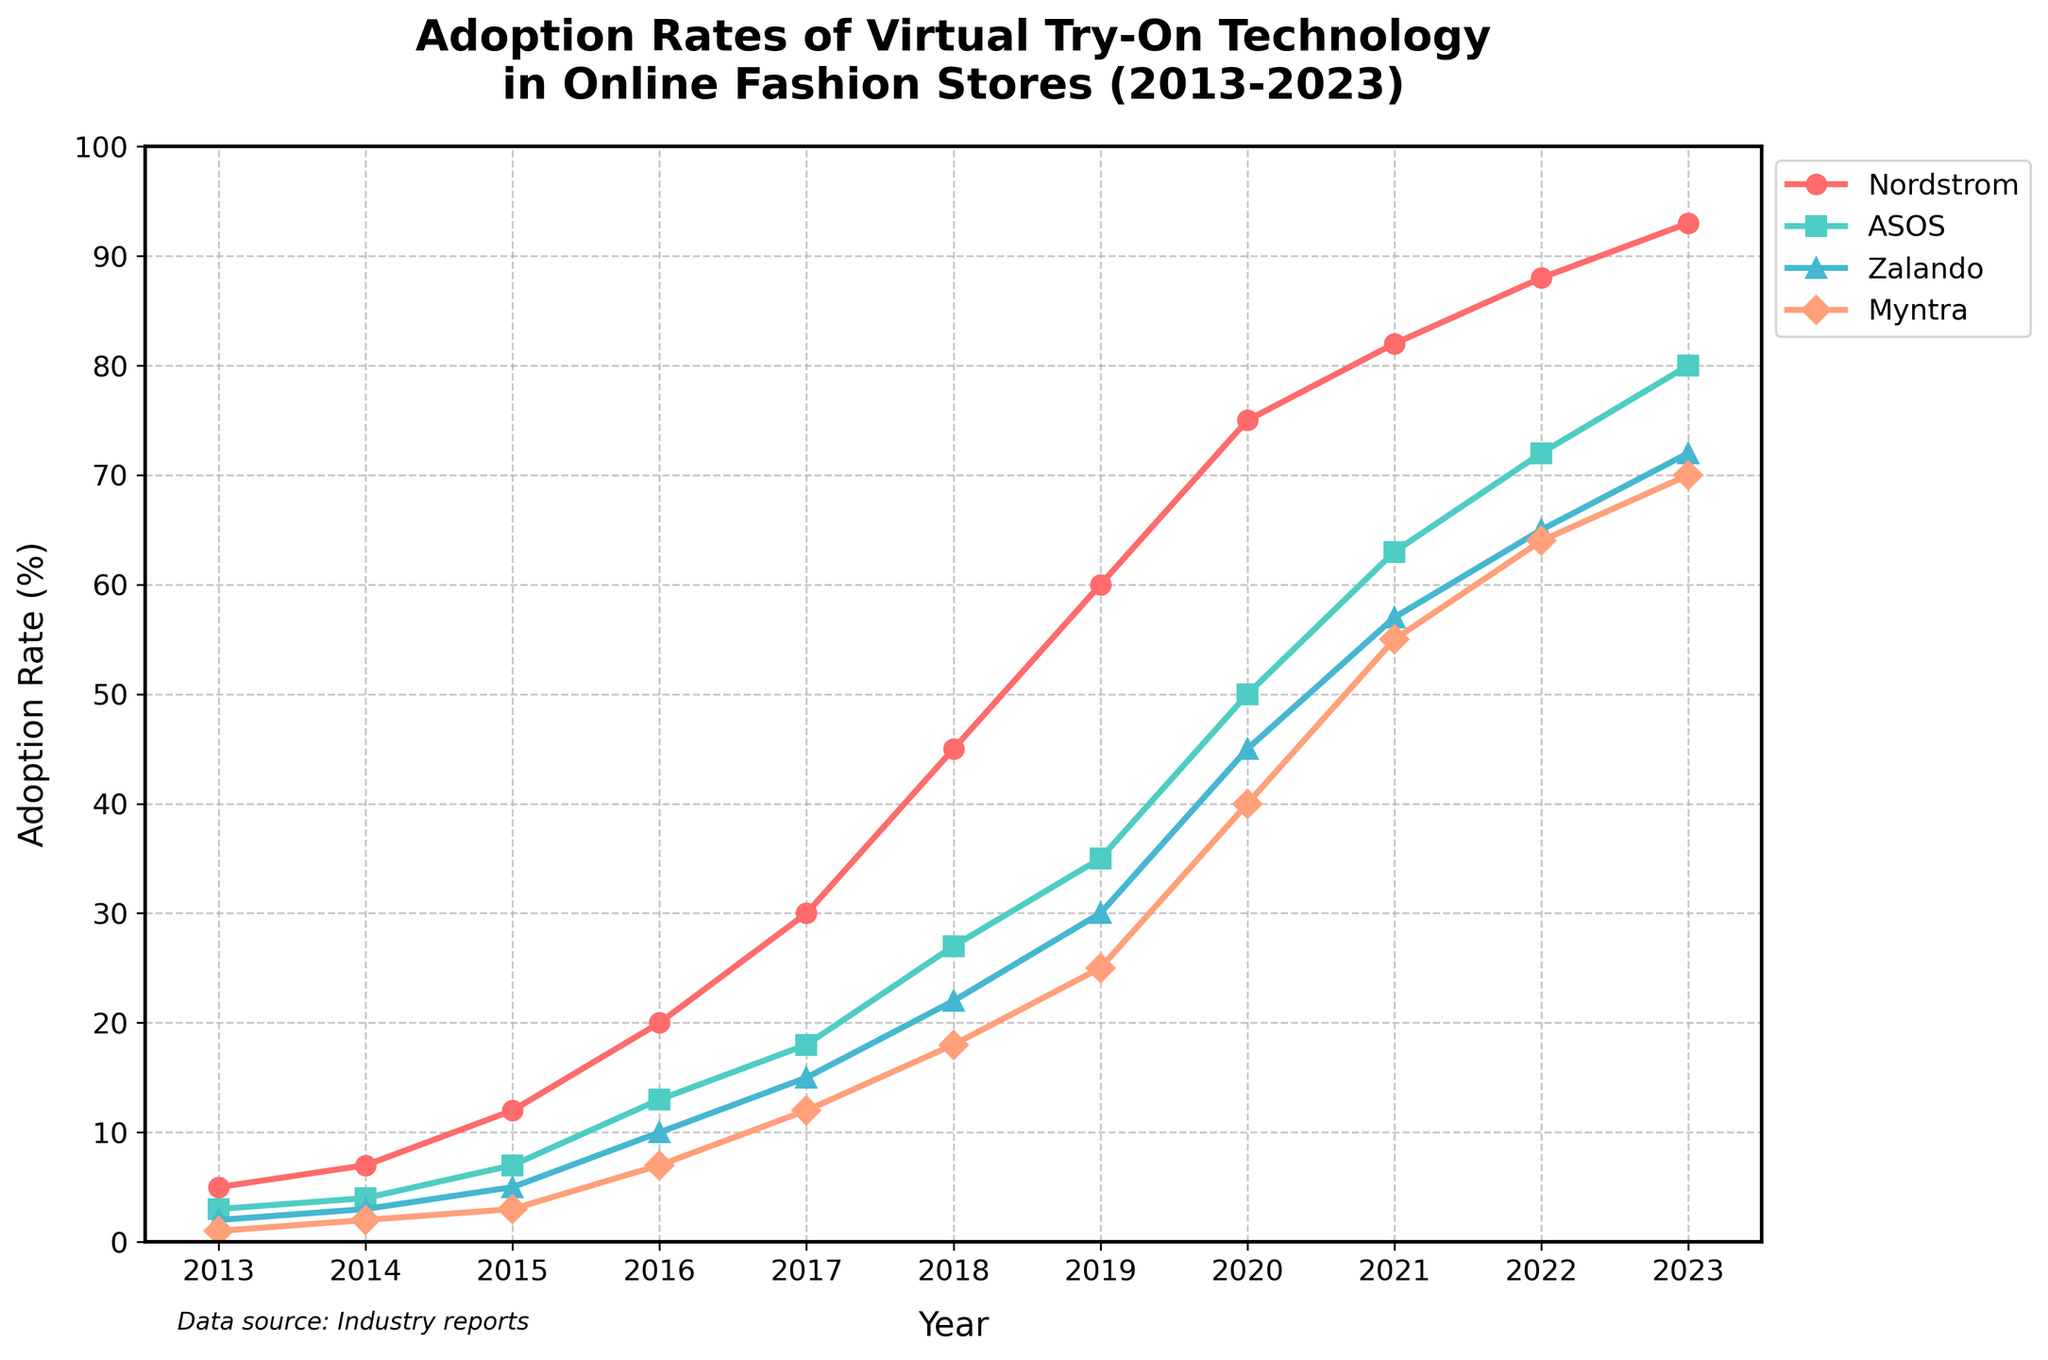what is the title of the figure? The title is typically located at the top of the plot. It provides a summary of what is being shown in the chart. In this case, the title reads "Adoption Rates of Virtual Try-On Technology in Online Fashion Stores (2013-2023)".
Answer: Adoption Rates of Virtual Try-On Technology in Online Fashion Stores (2013-2023) which company had the highest adoption rate in 2023? To find out which company had the highest adoption rate in 2023, look at the end points of each line on the far right of the graph. The highest point on the y-axis corresponds to Nordstrom, which had an adoption rate of 93%.
Answer: Nordstrom between which years did ASOS see the steepest rise in adoption rates? To identify the period with the steepest rise, look at the slope of the line for ASOS. Rapid increases are indicated by steeper slopes. Between 2019 and 2020, the line is steepest, suggesting the largest increase in that period.
Answer: 2019-2020 how much did Zalando's adoption rate increase from 2016 to 2019? First, note Zalando's adoption rates for 2016 and 2019. In 2016, the rate was 10%, and in 2019, it was 30%. The increase is calculated as 30% - 10% = 20%.
Answer: 20% which company had the slowest initial adoption rate from 2013 to 2015? Compare the slopes of each line from 2013 to 2015. The line with the smallest slope indicates the slowest adoption rate. Myntra had the smallest increase, moving from 1% to 3%.
Answer: Myntra in what year did all four companies exceed a 50% adoption rate? Look at the y-axis and find the 50% mark. Then trace horizontally to see when all four lines cross this threshold. The year when all companies exceed 50% is 2021.
Answer: 2021 which company showed a consistent rise in adoption rates every year without any decline? Examine the trajectories of all four lines. Nordstrom's adoption rate increases every year without any decline, showing a consistent rise.
Answer: Nordstrom did ASOS or Myntra have the bigger increase in adoption rate between 2017 and 2023? Calculate the difference in adoption rates for ASOS and Myntra between 2017 and 2023. For ASOS, the increase is 80% - 18% = 62%. For Myntra, it is 70% - 12% = 58%. ASOS has the bigger increase.
Answer: ASOS which company had the smallest adoption rate difference between 2013 and 2023? Calculate the absolute differences for each company over the period: Nordstrom (93% - 5%), ASOS (80% - 3%), Zalando (72% - 2%), Myntra (70% - 1%). Zalando has the smallest difference, 72% - 2% = 70%.
Answer: Zalando how did the adoption rates for Myntra change between 2014 and 2022? First, note Myntra's adoption rates in 2014 and 2022. In 2014, the rate was 2%. By 2022, it had risen to 64%. The change is calculated as 64% - 2% = 62%.
Answer: 62% 